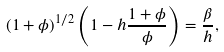<formula> <loc_0><loc_0><loc_500><loc_500>( 1 + \phi ) ^ { 1 / 2 } \left ( 1 - h \frac { 1 + \phi } { \phi } \right ) = \frac { \beta } { h } ,</formula> 